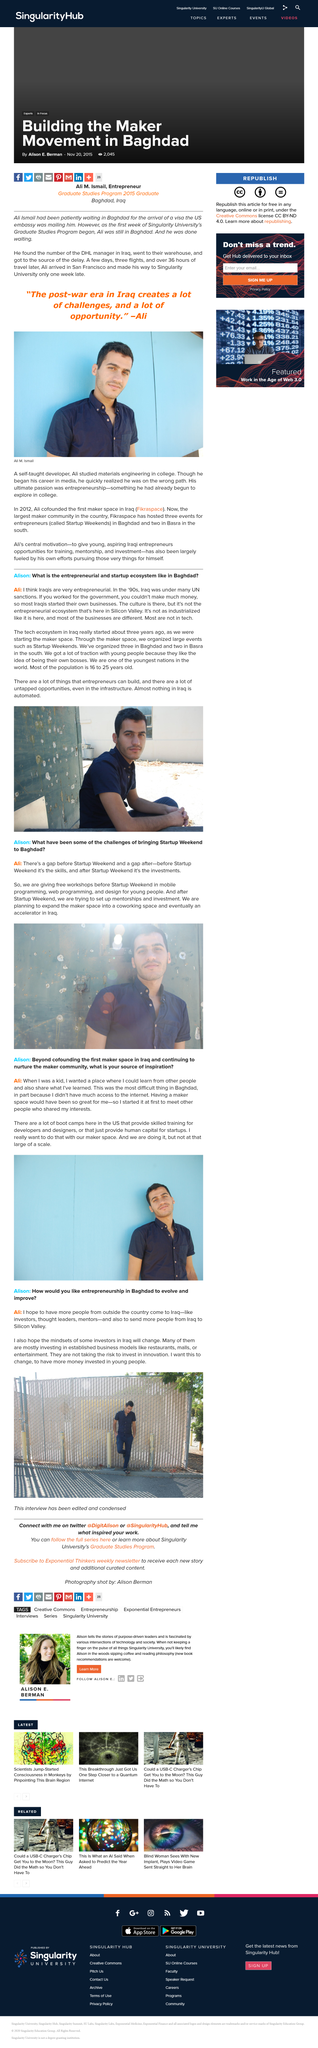Point out several critical features in this image. The person in the photo is Ali M. Ismail. The maker space, which was previously being converted, is now being transformed into a co-working space. The tech ecosystem in Iraq began approximately three years ago. Alison interviewed Ali, and Ali was interviewed by Alison. Ali hopes that the Iraqis will go to Silicon Valley. 